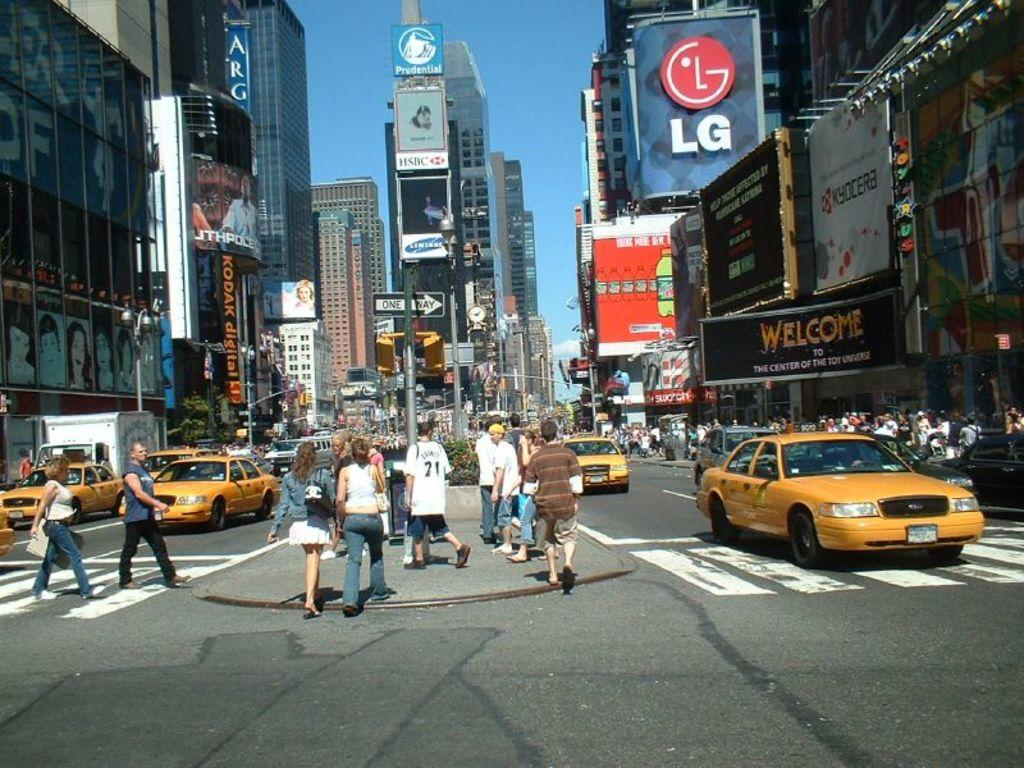<image>
Render a clear and concise summary of the photo. An LG logo can be seen on a sign on a busy city street. 